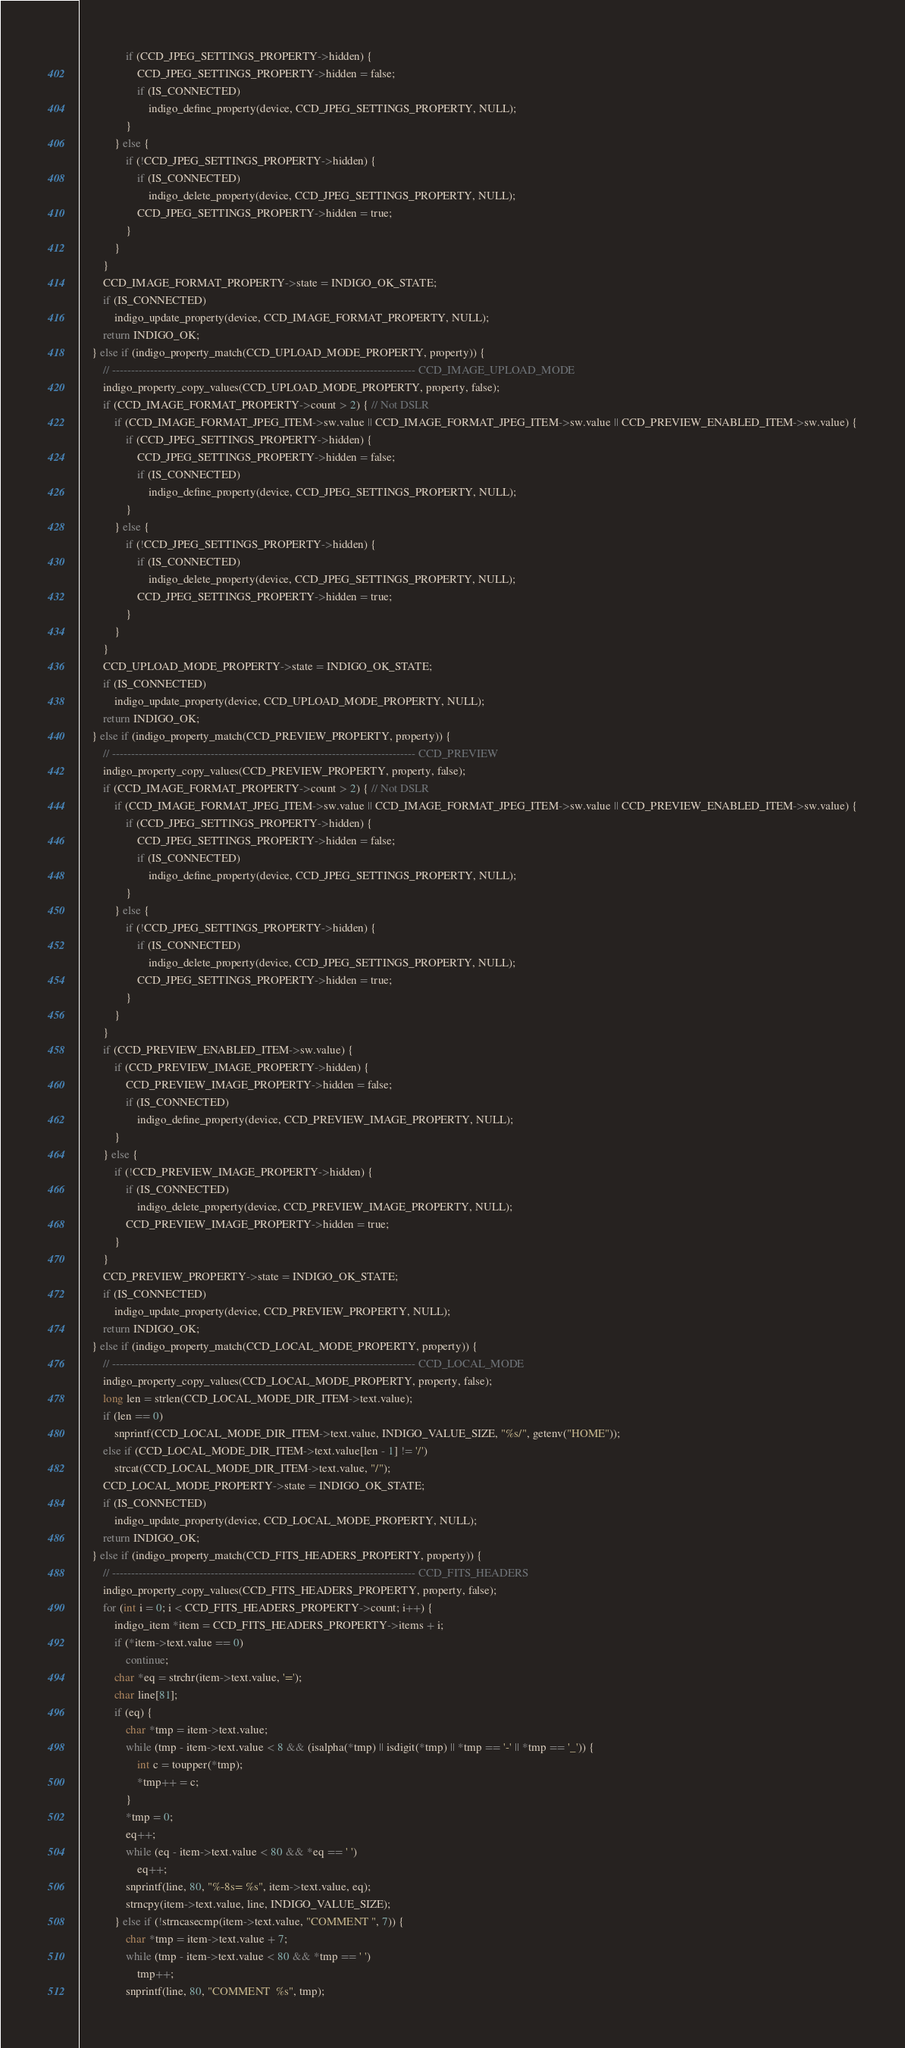Convert code to text. <code><loc_0><loc_0><loc_500><loc_500><_C_>				if (CCD_JPEG_SETTINGS_PROPERTY->hidden) {
					CCD_JPEG_SETTINGS_PROPERTY->hidden = false;
					if (IS_CONNECTED)
						indigo_define_property(device, CCD_JPEG_SETTINGS_PROPERTY, NULL);
				}
			} else {
				if (!CCD_JPEG_SETTINGS_PROPERTY->hidden) {
					if (IS_CONNECTED)
						indigo_delete_property(device, CCD_JPEG_SETTINGS_PROPERTY, NULL);
					CCD_JPEG_SETTINGS_PROPERTY->hidden = true;
				}
			}
		}
		CCD_IMAGE_FORMAT_PROPERTY->state = INDIGO_OK_STATE;
		if (IS_CONNECTED)
			indigo_update_property(device, CCD_IMAGE_FORMAT_PROPERTY, NULL);
		return INDIGO_OK;
	} else if (indigo_property_match(CCD_UPLOAD_MODE_PROPERTY, property)) {
		// -------------------------------------------------------------------------------- CCD_IMAGE_UPLOAD_MODE
		indigo_property_copy_values(CCD_UPLOAD_MODE_PROPERTY, property, false);
		if (CCD_IMAGE_FORMAT_PROPERTY->count > 2) { // Not DSLR
			if (CCD_IMAGE_FORMAT_JPEG_ITEM->sw.value || CCD_IMAGE_FORMAT_JPEG_ITEM->sw.value || CCD_PREVIEW_ENABLED_ITEM->sw.value) {
				if (CCD_JPEG_SETTINGS_PROPERTY->hidden) {
					CCD_JPEG_SETTINGS_PROPERTY->hidden = false;
					if (IS_CONNECTED)
						indigo_define_property(device, CCD_JPEG_SETTINGS_PROPERTY, NULL);
				}
			} else {
				if (!CCD_JPEG_SETTINGS_PROPERTY->hidden) {
					if (IS_CONNECTED)
						indigo_delete_property(device, CCD_JPEG_SETTINGS_PROPERTY, NULL);
					CCD_JPEG_SETTINGS_PROPERTY->hidden = true;
				}
			}
		}
		CCD_UPLOAD_MODE_PROPERTY->state = INDIGO_OK_STATE;
		if (IS_CONNECTED)
			indigo_update_property(device, CCD_UPLOAD_MODE_PROPERTY, NULL);
		return INDIGO_OK;
	} else if (indigo_property_match(CCD_PREVIEW_PROPERTY, property)) {
		// -------------------------------------------------------------------------------- CCD_PREVIEW
		indigo_property_copy_values(CCD_PREVIEW_PROPERTY, property, false);
		if (CCD_IMAGE_FORMAT_PROPERTY->count > 2) { // Not DSLR
			if (CCD_IMAGE_FORMAT_JPEG_ITEM->sw.value || CCD_IMAGE_FORMAT_JPEG_ITEM->sw.value || CCD_PREVIEW_ENABLED_ITEM->sw.value) {
				if (CCD_JPEG_SETTINGS_PROPERTY->hidden) {
					CCD_JPEG_SETTINGS_PROPERTY->hidden = false;
					if (IS_CONNECTED)
						indigo_define_property(device, CCD_JPEG_SETTINGS_PROPERTY, NULL);
				}
			} else {
				if (!CCD_JPEG_SETTINGS_PROPERTY->hidden) {
					if (IS_CONNECTED)
						indigo_delete_property(device, CCD_JPEG_SETTINGS_PROPERTY, NULL);
					CCD_JPEG_SETTINGS_PROPERTY->hidden = true;
				}
			}
		}
		if (CCD_PREVIEW_ENABLED_ITEM->sw.value) {
			if (CCD_PREVIEW_IMAGE_PROPERTY->hidden) {
				CCD_PREVIEW_IMAGE_PROPERTY->hidden = false;
				if (IS_CONNECTED)
					indigo_define_property(device, CCD_PREVIEW_IMAGE_PROPERTY, NULL);
			}
		} else {
			if (!CCD_PREVIEW_IMAGE_PROPERTY->hidden) {
				if (IS_CONNECTED)
					indigo_delete_property(device, CCD_PREVIEW_IMAGE_PROPERTY, NULL);
				CCD_PREVIEW_IMAGE_PROPERTY->hidden = true;
			}
		}
		CCD_PREVIEW_PROPERTY->state = INDIGO_OK_STATE;
		if (IS_CONNECTED)
			indigo_update_property(device, CCD_PREVIEW_PROPERTY, NULL);
		return INDIGO_OK;
	} else if (indigo_property_match(CCD_LOCAL_MODE_PROPERTY, property)) {
		// -------------------------------------------------------------------------------- CCD_LOCAL_MODE
		indigo_property_copy_values(CCD_LOCAL_MODE_PROPERTY, property, false);
		long len = strlen(CCD_LOCAL_MODE_DIR_ITEM->text.value);
		if (len == 0)
			snprintf(CCD_LOCAL_MODE_DIR_ITEM->text.value, INDIGO_VALUE_SIZE, "%s/", getenv("HOME"));
		else if (CCD_LOCAL_MODE_DIR_ITEM->text.value[len - 1] != '/')
			strcat(CCD_LOCAL_MODE_DIR_ITEM->text.value, "/");
		CCD_LOCAL_MODE_PROPERTY->state = INDIGO_OK_STATE;
		if (IS_CONNECTED)
			indigo_update_property(device, CCD_LOCAL_MODE_PROPERTY, NULL);
		return INDIGO_OK;
	} else if (indigo_property_match(CCD_FITS_HEADERS_PROPERTY, property)) {
		// -------------------------------------------------------------------------------- CCD_FITS_HEADERS
		indigo_property_copy_values(CCD_FITS_HEADERS_PROPERTY, property, false);
		for (int i = 0; i < CCD_FITS_HEADERS_PROPERTY->count; i++) {
			indigo_item *item = CCD_FITS_HEADERS_PROPERTY->items + i;
			if (*item->text.value == 0)
				continue;
			char *eq = strchr(item->text.value, '=');
			char line[81];
			if (eq) {
				char *tmp = item->text.value;
				while (tmp - item->text.value < 8 && (isalpha(*tmp) || isdigit(*tmp) || *tmp == '-' || *tmp == '_')) {
					int c = toupper(*tmp);
					*tmp++ = c;
				}
				*tmp = 0;
				eq++;
				while (eq - item->text.value < 80 && *eq == ' ')
					eq++;
				snprintf(line, 80, "%-8s= %s", item->text.value, eq);
				strncpy(item->text.value, line, INDIGO_VALUE_SIZE);
			} else if (!strncasecmp(item->text.value, "COMMENT ", 7)) {
				char *tmp = item->text.value + 7;
				while (tmp - item->text.value < 80 && *tmp == ' ')
					tmp++;
				snprintf(line, 80, "COMMENT  %s", tmp);</code> 